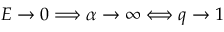<formula> <loc_0><loc_0><loc_500><loc_500>E \to 0 \Longrightarrow \alpha \to \infty \Longleftrightarrow q \to 1</formula> 